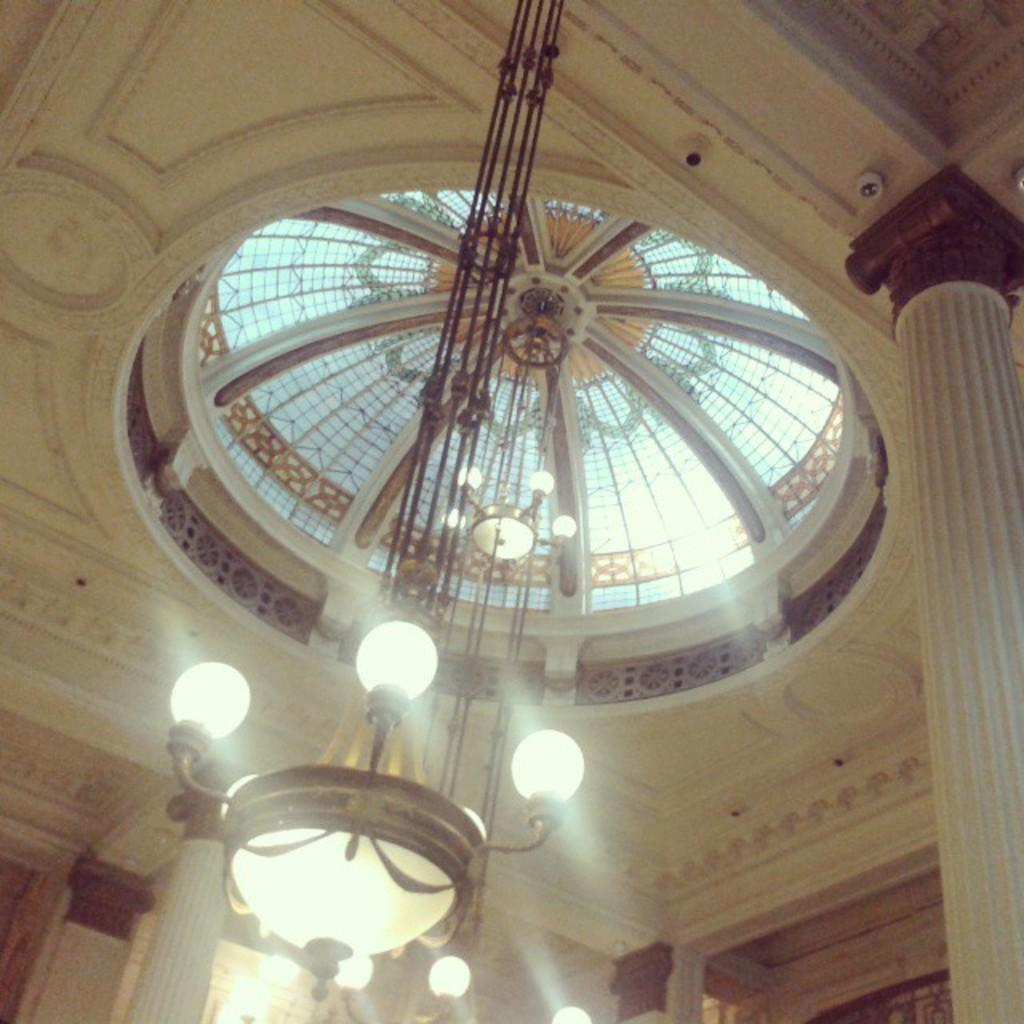What type of architectural feature is present in the image? There is a ceiling with a dome in the image. What is hanging from the ceiling? There are glasses on the ceiling. What type of lighting fixture is present in the image? A chandelier is present in the image. What supports the chandelier? There are pillars around the chandelier. What type of game is being played on the ceiling in the image? There is no game being played on the ceiling in the image. Can you see a kite flying in the image? There is no kite present in the image. 